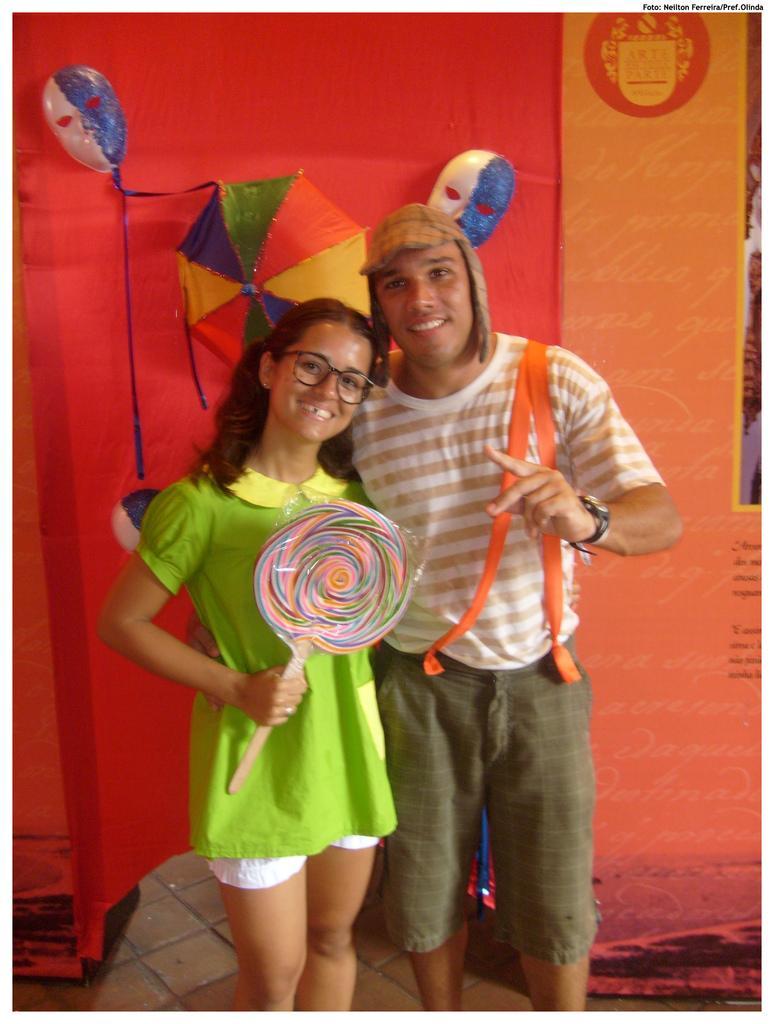Can you describe this image briefly? In the picture I can see a girl on the left side and she is smiling and beside to her there is a man. He is wearing a T-shirt and trouser. In the background, I can see the balloons on the red cloth. 